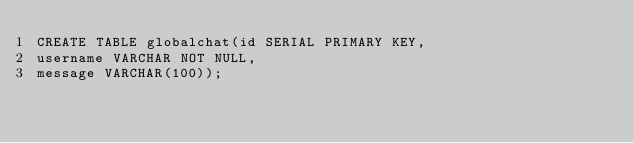Convert code to text. <code><loc_0><loc_0><loc_500><loc_500><_SQL_>CREATE TABLE globalchat(id SERIAL PRIMARY KEY,
username VARCHAR NOT NULL,
message VARCHAR(100));
</code> 